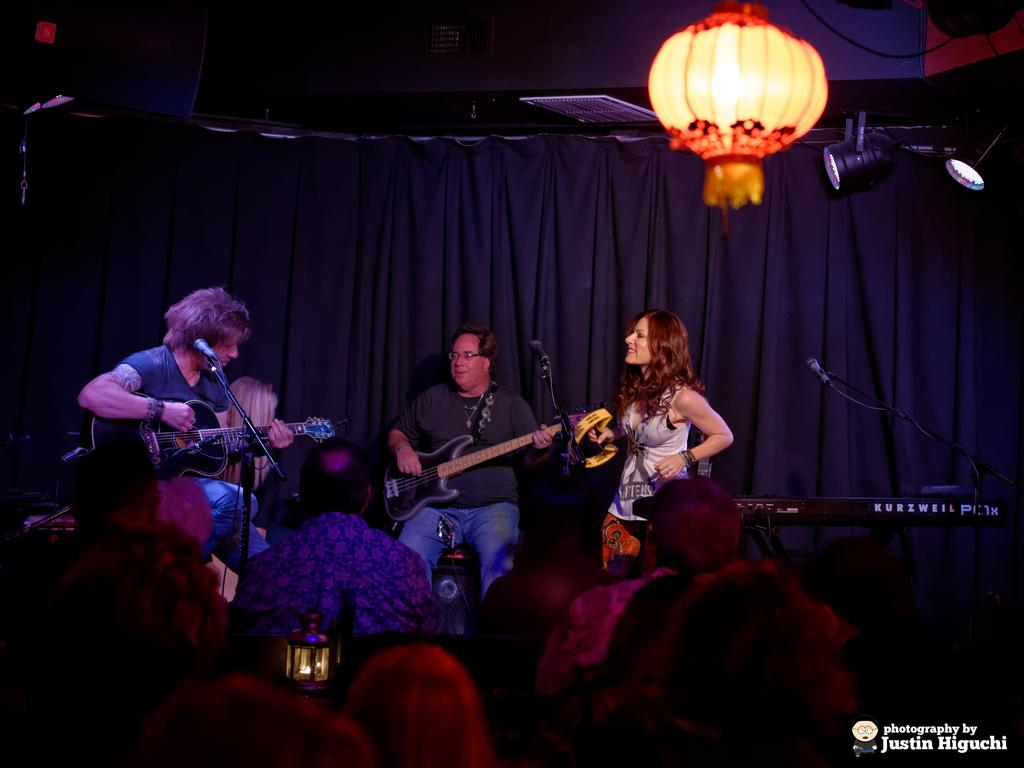What is happening on the stage in the image? There are two men and a woman performing on a stage. Can you describe the audience in the image? There are people watching the performance. What type of bears can be seen performing on the stage in the image? There are no bears present in the image; it features two men and a woman performing on a stage. How many horses are visible on the stage in the image? There are no horses present on the stage in the image. 